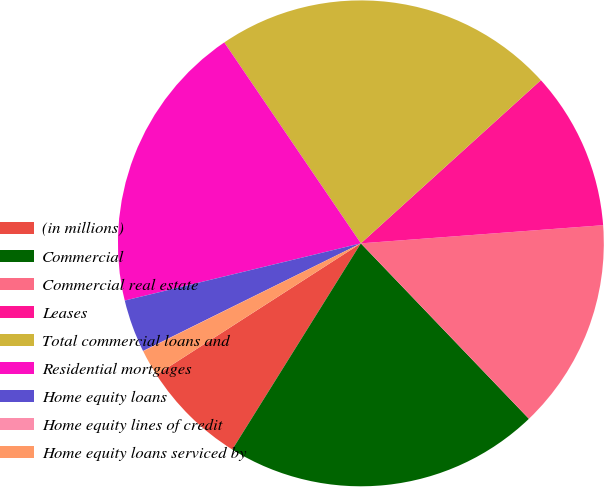<chart> <loc_0><loc_0><loc_500><loc_500><pie_chart><fcel>(in millions)<fcel>Commercial<fcel>Commercial real estate<fcel>Leases<fcel>Total commercial loans and<fcel>Residential mortgages<fcel>Home equity loans<fcel>Home equity lines of credit<fcel>Home equity loans serviced by<nl><fcel>7.03%<fcel>21.03%<fcel>14.03%<fcel>10.53%<fcel>22.78%<fcel>19.28%<fcel>3.52%<fcel>0.02%<fcel>1.77%<nl></chart> 